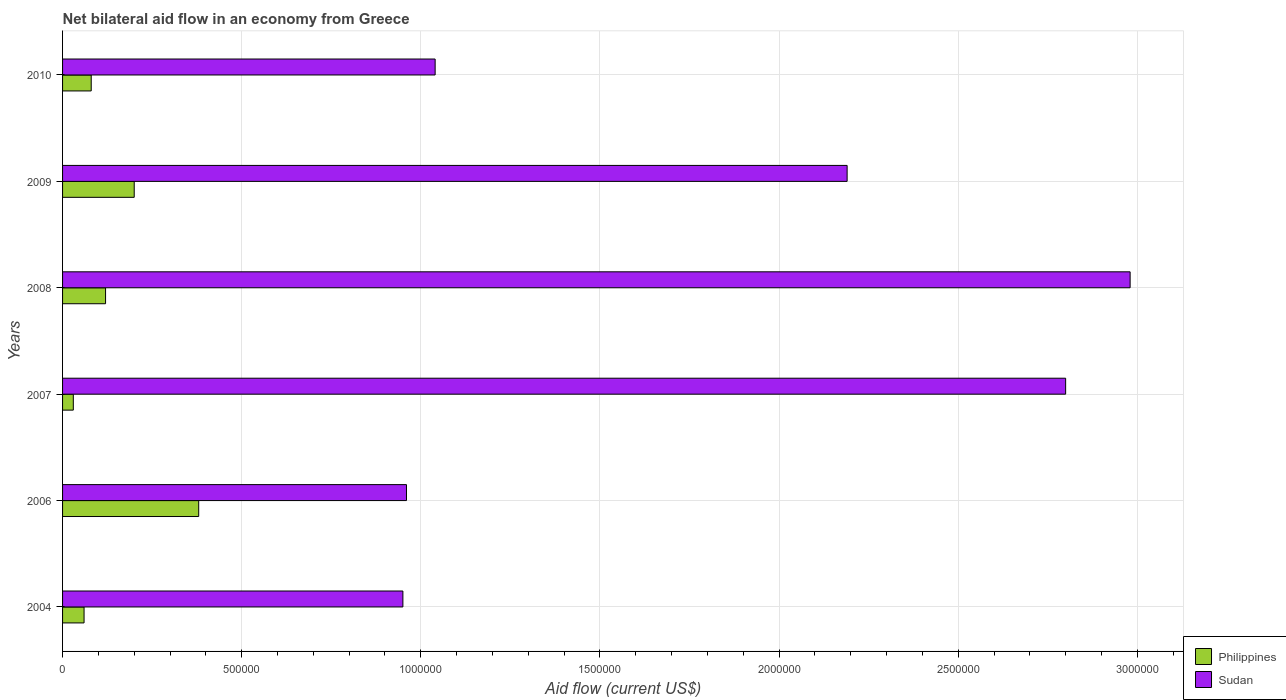How many different coloured bars are there?
Ensure brevity in your answer.  2. How many groups of bars are there?
Make the answer very short. 6. Are the number of bars on each tick of the Y-axis equal?
Offer a very short reply. Yes. How many bars are there on the 1st tick from the top?
Offer a terse response. 2. How many bars are there on the 2nd tick from the bottom?
Give a very brief answer. 2. What is the net bilateral aid flow in Sudan in 2009?
Make the answer very short. 2.19e+06. Across all years, what is the maximum net bilateral aid flow in Sudan?
Your response must be concise. 2.98e+06. In which year was the net bilateral aid flow in Philippines minimum?
Give a very brief answer. 2007. What is the total net bilateral aid flow in Philippines in the graph?
Your answer should be compact. 8.70e+05. What is the difference between the net bilateral aid flow in Sudan in 2004 and that in 2010?
Give a very brief answer. -9.00e+04. What is the difference between the net bilateral aid flow in Sudan in 2004 and the net bilateral aid flow in Philippines in 2008?
Keep it short and to the point. 8.30e+05. What is the average net bilateral aid flow in Sudan per year?
Offer a terse response. 1.82e+06. In the year 2009, what is the difference between the net bilateral aid flow in Philippines and net bilateral aid flow in Sudan?
Offer a very short reply. -1.99e+06. In how many years, is the net bilateral aid flow in Sudan greater than 400000 US$?
Ensure brevity in your answer.  6. What is the ratio of the net bilateral aid flow in Philippines in 2007 to that in 2008?
Offer a terse response. 0.25. What is the difference between the highest and the lowest net bilateral aid flow in Philippines?
Ensure brevity in your answer.  3.50e+05. What does the 2nd bar from the bottom in 2004 represents?
Keep it short and to the point. Sudan. How many bars are there?
Ensure brevity in your answer.  12. Are the values on the major ticks of X-axis written in scientific E-notation?
Provide a short and direct response. No. Does the graph contain grids?
Provide a short and direct response. Yes. Where does the legend appear in the graph?
Offer a very short reply. Bottom right. How many legend labels are there?
Give a very brief answer. 2. What is the title of the graph?
Offer a very short reply. Net bilateral aid flow in an economy from Greece. What is the label or title of the Y-axis?
Your response must be concise. Years. What is the Aid flow (current US$) of Philippines in 2004?
Ensure brevity in your answer.  6.00e+04. What is the Aid flow (current US$) of Sudan in 2004?
Make the answer very short. 9.50e+05. What is the Aid flow (current US$) in Philippines in 2006?
Provide a succinct answer. 3.80e+05. What is the Aid flow (current US$) of Sudan in 2006?
Provide a succinct answer. 9.60e+05. What is the Aid flow (current US$) in Sudan in 2007?
Provide a succinct answer. 2.80e+06. What is the Aid flow (current US$) in Philippines in 2008?
Offer a terse response. 1.20e+05. What is the Aid flow (current US$) in Sudan in 2008?
Offer a very short reply. 2.98e+06. What is the Aid flow (current US$) of Sudan in 2009?
Your answer should be compact. 2.19e+06. What is the Aid flow (current US$) in Philippines in 2010?
Your answer should be compact. 8.00e+04. What is the Aid flow (current US$) of Sudan in 2010?
Make the answer very short. 1.04e+06. Across all years, what is the maximum Aid flow (current US$) in Philippines?
Your response must be concise. 3.80e+05. Across all years, what is the maximum Aid flow (current US$) of Sudan?
Offer a very short reply. 2.98e+06. Across all years, what is the minimum Aid flow (current US$) in Philippines?
Offer a very short reply. 3.00e+04. Across all years, what is the minimum Aid flow (current US$) in Sudan?
Offer a terse response. 9.50e+05. What is the total Aid flow (current US$) of Philippines in the graph?
Provide a short and direct response. 8.70e+05. What is the total Aid flow (current US$) of Sudan in the graph?
Keep it short and to the point. 1.09e+07. What is the difference between the Aid flow (current US$) in Philippines in 2004 and that in 2006?
Provide a succinct answer. -3.20e+05. What is the difference between the Aid flow (current US$) of Sudan in 2004 and that in 2006?
Provide a succinct answer. -10000. What is the difference between the Aid flow (current US$) in Philippines in 2004 and that in 2007?
Provide a short and direct response. 3.00e+04. What is the difference between the Aid flow (current US$) of Sudan in 2004 and that in 2007?
Provide a short and direct response. -1.85e+06. What is the difference between the Aid flow (current US$) of Philippines in 2004 and that in 2008?
Keep it short and to the point. -6.00e+04. What is the difference between the Aid flow (current US$) of Sudan in 2004 and that in 2008?
Provide a succinct answer. -2.03e+06. What is the difference between the Aid flow (current US$) of Philippines in 2004 and that in 2009?
Your answer should be very brief. -1.40e+05. What is the difference between the Aid flow (current US$) of Sudan in 2004 and that in 2009?
Your response must be concise. -1.24e+06. What is the difference between the Aid flow (current US$) in Philippines in 2004 and that in 2010?
Provide a short and direct response. -2.00e+04. What is the difference between the Aid flow (current US$) of Philippines in 2006 and that in 2007?
Make the answer very short. 3.50e+05. What is the difference between the Aid flow (current US$) in Sudan in 2006 and that in 2007?
Keep it short and to the point. -1.84e+06. What is the difference between the Aid flow (current US$) in Philippines in 2006 and that in 2008?
Make the answer very short. 2.60e+05. What is the difference between the Aid flow (current US$) of Sudan in 2006 and that in 2008?
Keep it short and to the point. -2.02e+06. What is the difference between the Aid flow (current US$) of Philippines in 2006 and that in 2009?
Offer a terse response. 1.80e+05. What is the difference between the Aid flow (current US$) of Sudan in 2006 and that in 2009?
Make the answer very short. -1.23e+06. What is the difference between the Aid flow (current US$) of Philippines in 2006 and that in 2010?
Offer a very short reply. 3.00e+05. What is the difference between the Aid flow (current US$) in Sudan in 2006 and that in 2010?
Make the answer very short. -8.00e+04. What is the difference between the Aid flow (current US$) of Sudan in 2007 and that in 2008?
Give a very brief answer. -1.80e+05. What is the difference between the Aid flow (current US$) of Sudan in 2007 and that in 2009?
Offer a very short reply. 6.10e+05. What is the difference between the Aid flow (current US$) in Sudan in 2007 and that in 2010?
Offer a terse response. 1.76e+06. What is the difference between the Aid flow (current US$) in Sudan in 2008 and that in 2009?
Give a very brief answer. 7.90e+05. What is the difference between the Aid flow (current US$) in Philippines in 2008 and that in 2010?
Your answer should be very brief. 4.00e+04. What is the difference between the Aid flow (current US$) of Sudan in 2008 and that in 2010?
Offer a very short reply. 1.94e+06. What is the difference between the Aid flow (current US$) of Sudan in 2009 and that in 2010?
Your response must be concise. 1.15e+06. What is the difference between the Aid flow (current US$) of Philippines in 2004 and the Aid flow (current US$) of Sudan in 2006?
Give a very brief answer. -9.00e+05. What is the difference between the Aid flow (current US$) in Philippines in 2004 and the Aid flow (current US$) in Sudan in 2007?
Your answer should be very brief. -2.74e+06. What is the difference between the Aid flow (current US$) in Philippines in 2004 and the Aid flow (current US$) in Sudan in 2008?
Offer a very short reply. -2.92e+06. What is the difference between the Aid flow (current US$) of Philippines in 2004 and the Aid flow (current US$) of Sudan in 2009?
Your answer should be very brief. -2.13e+06. What is the difference between the Aid flow (current US$) in Philippines in 2004 and the Aid flow (current US$) in Sudan in 2010?
Provide a short and direct response. -9.80e+05. What is the difference between the Aid flow (current US$) of Philippines in 2006 and the Aid flow (current US$) of Sudan in 2007?
Your answer should be very brief. -2.42e+06. What is the difference between the Aid flow (current US$) of Philippines in 2006 and the Aid flow (current US$) of Sudan in 2008?
Offer a terse response. -2.60e+06. What is the difference between the Aid flow (current US$) of Philippines in 2006 and the Aid flow (current US$) of Sudan in 2009?
Offer a very short reply. -1.81e+06. What is the difference between the Aid flow (current US$) of Philippines in 2006 and the Aid flow (current US$) of Sudan in 2010?
Your answer should be compact. -6.60e+05. What is the difference between the Aid flow (current US$) of Philippines in 2007 and the Aid flow (current US$) of Sudan in 2008?
Offer a very short reply. -2.95e+06. What is the difference between the Aid flow (current US$) of Philippines in 2007 and the Aid flow (current US$) of Sudan in 2009?
Your answer should be very brief. -2.16e+06. What is the difference between the Aid flow (current US$) of Philippines in 2007 and the Aid flow (current US$) of Sudan in 2010?
Offer a very short reply. -1.01e+06. What is the difference between the Aid flow (current US$) in Philippines in 2008 and the Aid flow (current US$) in Sudan in 2009?
Ensure brevity in your answer.  -2.07e+06. What is the difference between the Aid flow (current US$) of Philippines in 2008 and the Aid flow (current US$) of Sudan in 2010?
Offer a terse response. -9.20e+05. What is the difference between the Aid flow (current US$) in Philippines in 2009 and the Aid flow (current US$) in Sudan in 2010?
Give a very brief answer. -8.40e+05. What is the average Aid flow (current US$) in Philippines per year?
Offer a very short reply. 1.45e+05. What is the average Aid flow (current US$) in Sudan per year?
Make the answer very short. 1.82e+06. In the year 2004, what is the difference between the Aid flow (current US$) of Philippines and Aid flow (current US$) of Sudan?
Your answer should be very brief. -8.90e+05. In the year 2006, what is the difference between the Aid flow (current US$) of Philippines and Aid flow (current US$) of Sudan?
Your answer should be compact. -5.80e+05. In the year 2007, what is the difference between the Aid flow (current US$) in Philippines and Aid flow (current US$) in Sudan?
Offer a terse response. -2.77e+06. In the year 2008, what is the difference between the Aid flow (current US$) in Philippines and Aid flow (current US$) in Sudan?
Give a very brief answer. -2.86e+06. In the year 2009, what is the difference between the Aid flow (current US$) in Philippines and Aid flow (current US$) in Sudan?
Give a very brief answer. -1.99e+06. In the year 2010, what is the difference between the Aid flow (current US$) in Philippines and Aid flow (current US$) in Sudan?
Your answer should be compact. -9.60e+05. What is the ratio of the Aid flow (current US$) of Philippines in 2004 to that in 2006?
Provide a short and direct response. 0.16. What is the ratio of the Aid flow (current US$) in Sudan in 2004 to that in 2006?
Provide a succinct answer. 0.99. What is the ratio of the Aid flow (current US$) in Philippines in 2004 to that in 2007?
Provide a short and direct response. 2. What is the ratio of the Aid flow (current US$) in Sudan in 2004 to that in 2007?
Provide a short and direct response. 0.34. What is the ratio of the Aid flow (current US$) in Sudan in 2004 to that in 2008?
Your response must be concise. 0.32. What is the ratio of the Aid flow (current US$) of Philippines in 2004 to that in 2009?
Ensure brevity in your answer.  0.3. What is the ratio of the Aid flow (current US$) in Sudan in 2004 to that in 2009?
Keep it short and to the point. 0.43. What is the ratio of the Aid flow (current US$) of Sudan in 2004 to that in 2010?
Your response must be concise. 0.91. What is the ratio of the Aid flow (current US$) of Philippines in 2006 to that in 2007?
Keep it short and to the point. 12.67. What is the ratio of the Aid flow (current US$) of Sudan in 2006 to that in 2007?
Your answer should be very brief. 0.34. What is the ratio of the Aid flow (current US$) in Philippines in 2006 to that in 2008?
Offer a very short reply. 3.17. What is the ratio of the Aid flow (current US$) in Sudan in 2006 to that in 2008?
Offer a very short reply. 0.32. What is the ratio of the Aid flow (current US$) in Sudan in 2006 to that in 2009?
Keep it short and to the point. 0.44. What is the ratio of the Aid flow (current US$) of Philippines in 2006 to that in 2010?
Your answer should be very brief. 4.75. What is the ratio of the Aid flow (current US$) of Sudan in 2007 to that in 2008?
Your answer should be very brief. 0.94. What is the ratio of the Aid flow (current US$) in Philippines in 2007 to that in 2009?
Provide a short and direct response. 0.15. What is the ratio of the Aid flow (current US$) in Sudan in 2007 to that in 2009?
Give a very brief answer. 1.28. What is the ratio of the Aid flow (current US$) in Sudan in 2007 to that in 2010?
Offer a very short reply. 2.69. What is the ratio of the Aid flow (current US$) of Sudan in 2008 to that in 2009?
Provide a short and direct response. 1.36. What is the ratio of the Aid flow (current US$) of Philippines in 2008 to that in 2010?
Offer a terse response. 1.5. What is the ratio of the Aid flow (current US$) in Sudan in 2008 to that in 2010?
Ensure brevity in your answer.  2.87. What is the ratio of the Aid flow (current US$) of Sudan in 2009 to that in 2010?
Your answer should be very brief. 2.11. What is the difference between the highest and the second highest Aid flow (current US$) of Philippines?
Give a very brief answer. 1.80e+05. What is the difference between the highest and the lowest Aid flow (current US$) in Sudan?
Your answer should be very brief. 2.03e+06. 